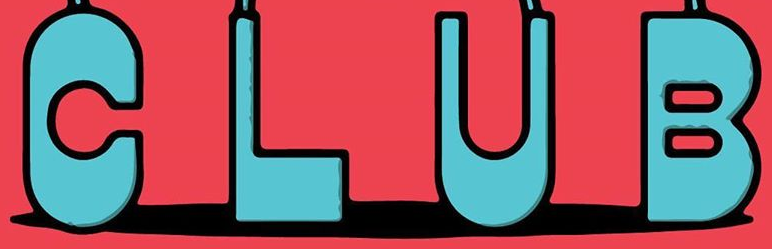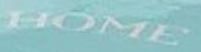What text is displayed in these images sequentially, separated by a semicolon? CLUB; HOME 